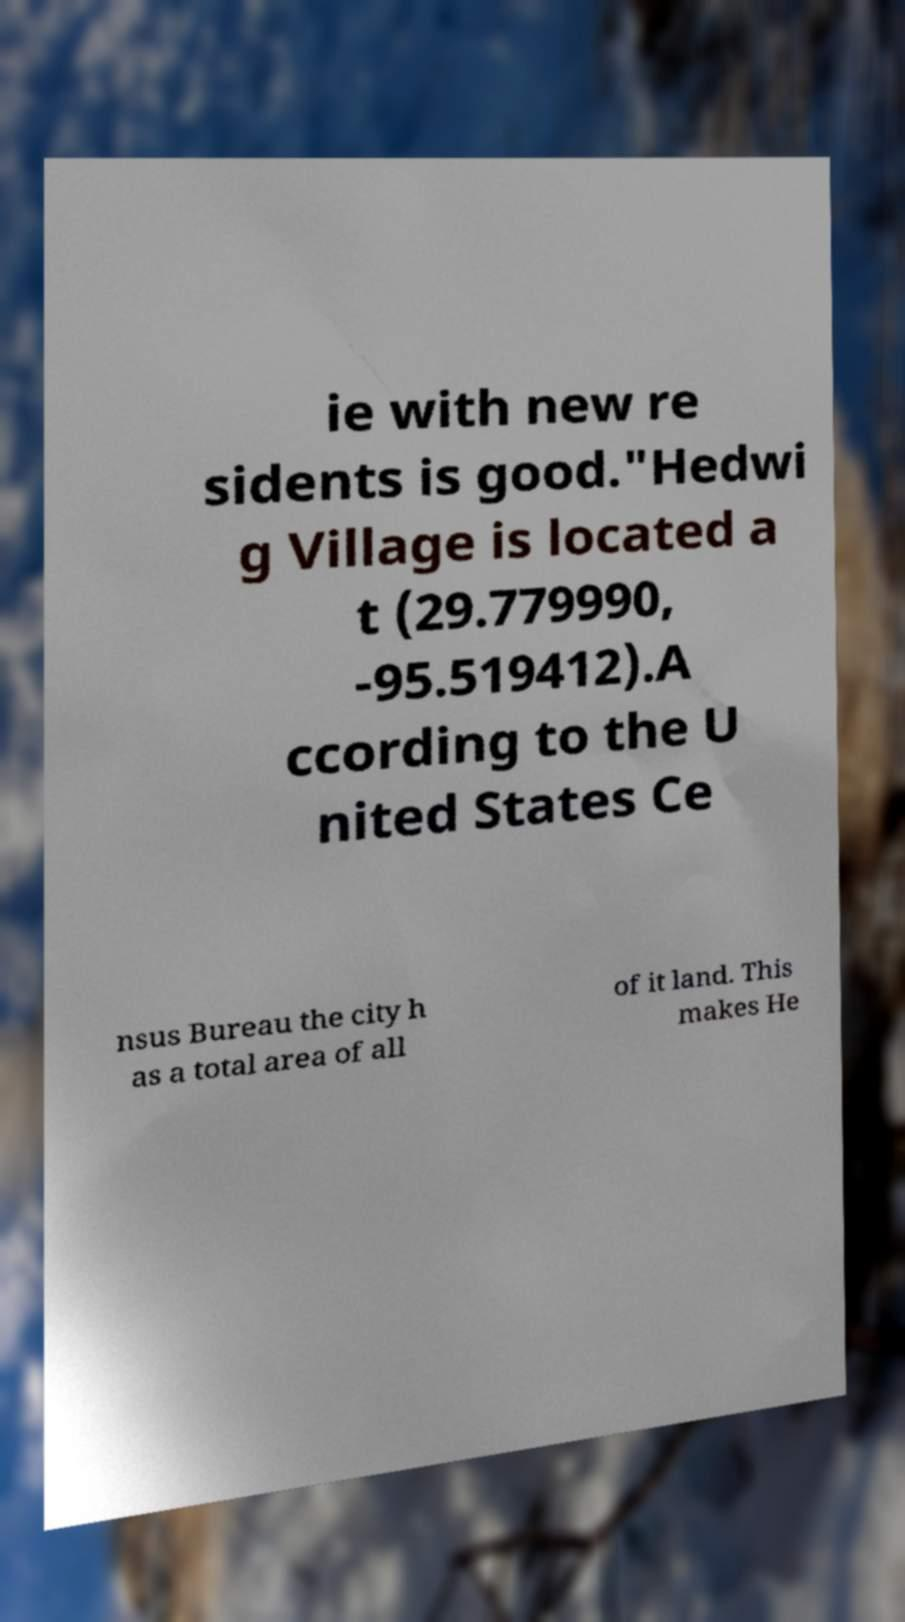For documentation purposes, I need the text within this image transcribed. Could you provide that? ie with new re sidents is good."Hedwi g Village is located a t (29.779990, -95.519412).A ccording to the U nited States Ce nsus Bureau the city h as a total area of all of it land. This makes He 